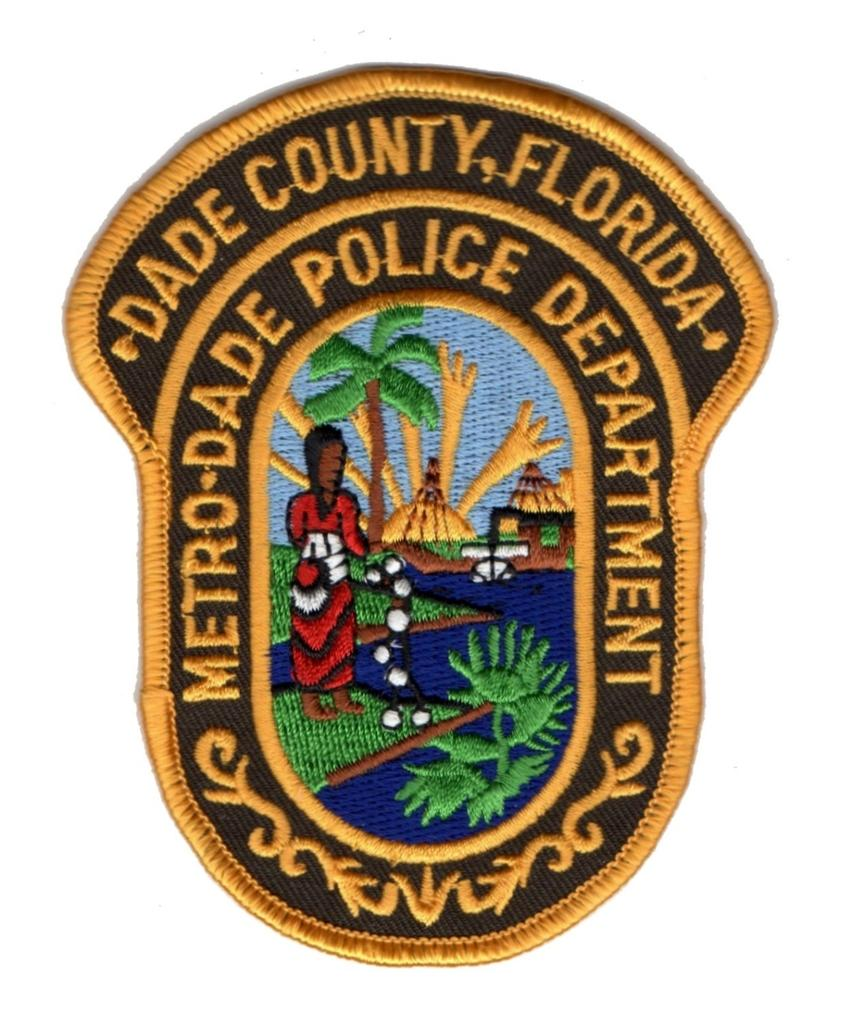What is the main object in the image? There is a badge in the image. What can be seen written on the badge? The badge has something written in yellow color. What natural elements are depicted in the image? There is a depiction of a tree, grass, plants, and water in the image. Are there any living beings depicted in the image? Yes, there is a depiction of a person in the image. What type of pies are being served on the stage in the image? There is no stage or pies present in the image; it features a badge with natural elements and a person. Can you tell me how many scissors are being used by the person in the image? There are no scissors visible in the image; the person is not using any tools or objects. 